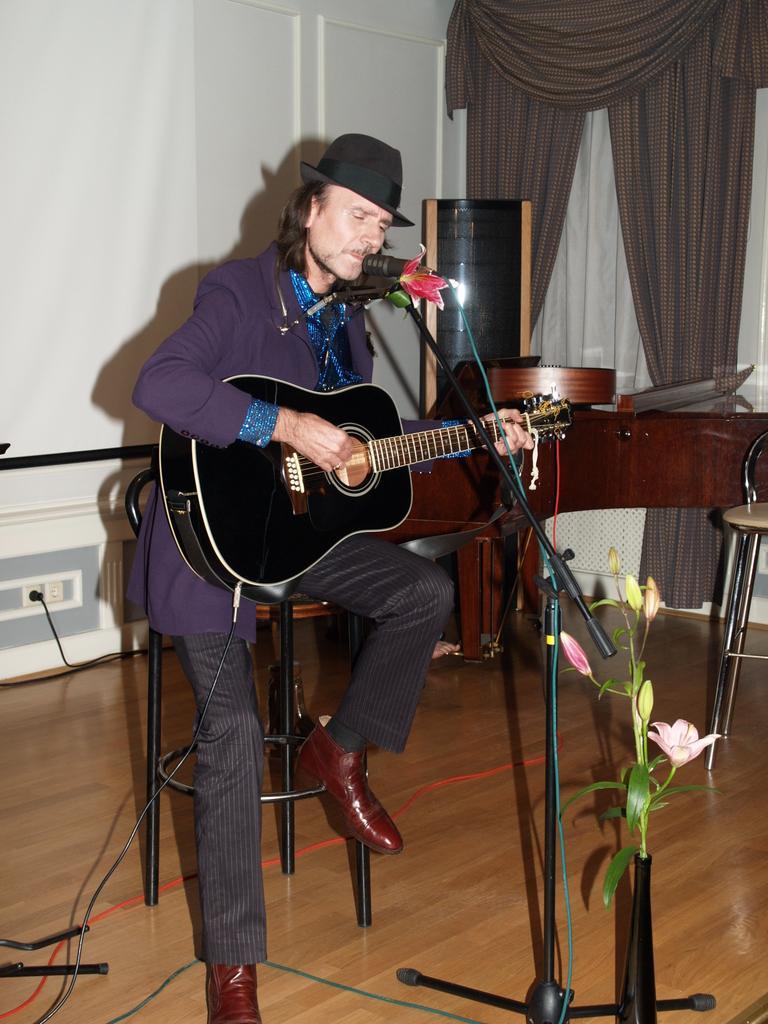In one or two sentences, can you explain what this image depicts? In this image i can see a man sitting on a chair and holding a guitar in his hand and he is also wearing a hat and brown shoes and on the background i can curtains and a wall , and in front of him i can see a mic and a flower bouquet. 